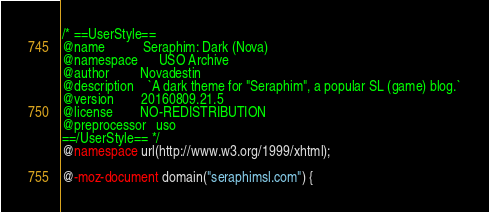Convert code to text. <code><loc_0><loc_0><loc_500><loc_500><_CSS_>/* ==UserStyle==
@name           Seraphim: Dark (Nova)
@namespace      USO Archive
@author         Novadestin
@description    `A dark theme for "Seraphim", a popular SL (game) blog.`
@version        20160809.21.5
@license        NO-REDISTRIBUTION
@preprocessor   uso
==/UserStyle== */
@namespace url(http://www.w3.org/1999/xhtml);

@-moz-document domain("seraphimsl.com") {
</code> 